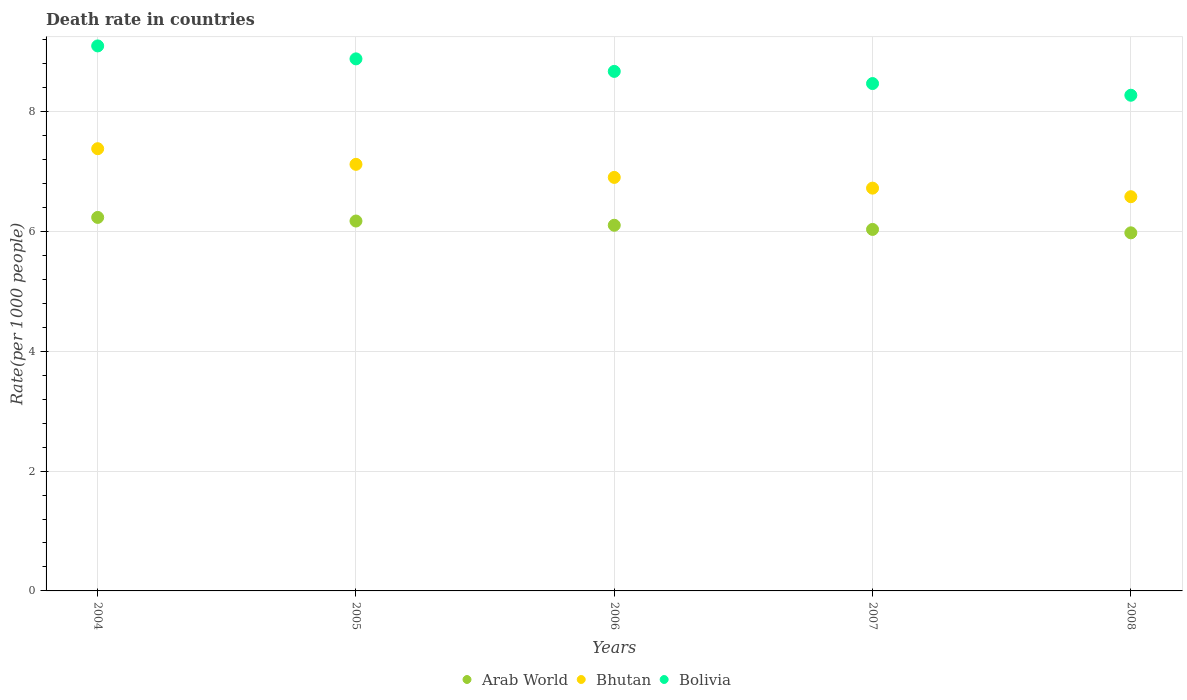How many different coloured dotlines are there?
Your answer should be compact. 3. What is the death rate in Bhutan in 2005?
Ensure brevity in your answer.  7.12. Across all years, what is the maximum death rate in Bolivia?
Keep it short and to the point. 9.09. Across all years, what is the minimum death rate in Arab World?
Offer a terse response. 5.98. In which year was the death rate in Bolivia maximum?
Your answer should be very brief. 2004. What is the total death rate in Arab World in the graph?
Provide a short and direct response. 30.51. What is the difference between the death rate in Arab World in 2004 and that in 2008?
Your response must be concise. 0.26. What is the difference between the death rate in Bolivia in 2006 and the death rate in Bhutan in 2008?
Provide a succinct answer. 2.09. What is the average death rate in Bhutan per year?
Offer a very short reply. 6.94. In the year 2005, what is the difference between the death rate in Bhutan and death rate in Bolivia?
Offer a terse response. -1.76. What is the ratio of the death rate in Bolivia in 2004 to that in 2008?
Your response must be concise. 1.1. Is the difference between the death rate in Bhutan in 2004 and 2007 greater than the difference between the death rate in Bolivia in 2004 and 2007?
Your response must be concise. Yes. What is the difference between the highest and the second highest death rate in Bhutan?
Offer a very short reply. 0.26. What is the difference between the highest and the lowest death rate in Bolivia?
Your answer should be compact. 0.82. In how many years, is the death rate in Bhutan greater than the average death rate in Bhutan taken over all years?
Offer a terse response. 2. Is it the case that in every year, the sum of the death rate in Bolivia and death rate in Bhutan  is greater than the death rate in Arab World?
Provide a short and direct response. Yes. How many dotlines are there?
Your response must be concise. 3. How many years are there in the graph?
Make the answer very short. 5. Are the values on the major ticks of Y-axis written in scientific E-notation?
Ensure brevity in your answer.  No. Does the graph contain any zero values?
Make the answer very short. No. How are the legend labels stacked?
Your answer should be very brief. Horizontal. What is the title of the graph?
Offer a terse response. Death rate in countries. What is the label or title of the X-axis?
Provide a short and direct response. Years. What is the label or title of the Y-axis?
Offer a terse response. Rate(per 1000 people). What is the Rate(per 1000 people) in Arab World in 2004?
Make the answer very short. 6.23. What is the Rate(per 1000 people) in Bhutan in 2004?
Keep it short and to the point. 7.38. What is the Rate(per 1000 people) of Bolivia in 2004?
Ensure brevity in your answer.  9.09. What is the Rate(per 1000 people) in Arab World in 2005?
Provide a short and direct response. 6.17. What is the Rate(per 1000 people) of Bhutan in 2005?
Ensure brevity in your answer.  7.12. What is the Rate(per 1000 people) of Bolivia in 2005?
Provide a succinct answer. 8.88. What is the Rate(per 1000 people) in Arab World in 2006?
Your answer should be very brief. 6.1. What is the Rate(per 1000 people) of Bolivia in 2006?
Your answer should be very brief. 8.67. What is the Rate(per 1000 people) in Arab World in 2007?
Your response must be concise. 6.03. What is the Rate(per 1000 people) in Bhutan in 2007?
Offer a very short reply. 6.72. What is the Rate(per 1000 people) of Bolivia in 2007?
Your response must be concise. 8.47. What is the Rate(per 1000 people) of Arab World in 2008?
Your answer should be very brief. 5.98. What is the Rate(per 1000 people) in Bhutan in 2008?
Your response must be concise. 6.58. What is the Rate(per 1000 people) in Bolivia in 2008?
Keep it short and to the point. 8.27. Across all years, what is the maximum Rate(per 1000 people) in Arab World?
Provide a short and direct response. 6.23. Across all years, what is the maximum Rate(per 1000 people) in Bhutan?
Offer a terse response. 7.38. Across all years, what is the maximum Rate(per 1000 people) of Bolivia?
Make the answer very short. 9.09. Across all years, what is the minimum Rate(per 1000 people) in Arab World?
Keep it short and to the point. 5.98. Across all years, what is the minimum Rate(per 1000 people) of Bhutan?
Provide a short and direct response. 6.58. Across all years, what is the minimum Rate(per 1000 people) of Bolivia?
Ensure brevity in your answer.  8.27. What is the total Rate(per 1000 people) in Arab World in the graph?
Ensure brevity in your answer.  30.51. What is the total Rate(per 1000 people) of Bhutan in the graph?
Provide a short and direct response. 34.7. What is the total Rate(per 1000 people) of Bolivia in the graph?
Make the answer very short. 43.38. What is the difference between the Rate(per 1000 people) of Arab World in 2004 and that in 2005?
Offer a terse response. 0.06. What is the difference between the Rate(per 1000 people) in Bhutan in 2004 and that in 2005?
Your answer should be compact. 0.26. What is the difference between the Rate(per 1000 people) in Bolivia in 2004 and that in 2005?
Offer a very short reply. 0.22. What is the difference between the Rate(per 1000 people) of Arab World in 2004 and that in 2006?
Provide a short and direct response. 0.13. What is the difference between the Rate(per 1000 people) in Bhutan in 2004 and that in 2006?
Provide a succinct answer. 0.48. What is the difference between the Rate(per 1000 people) in Bolivia in 2004 and that in 2006?
Provide a succinct answer. 0.42. What is the difference between the Rate(per 1000 people) of Arab World in 2004 and that in 2007?
Offer a very short reply. 0.2. What is the difference between the Rate(per 1000 people) of Bhutan in 2004 and that in 2007?
Make the answer very short. 0.66. What is the difference between the Rate(per 1000 people) in Bolivia in 2004 and that in 2007?
Make the answer very short. 0.63. What is the difference between the Rate(per 1000 people) in Arab World in 2004 and that in 2008?
Offer a terse response. 0.26. What is the difference between the Rate(per 1000 people) in Bhutan in 2004 and that in 2008?
Make the answer very short. 0.8. What is the difference between the Rate(per 1000 people) of Bolivia in 2004 and that in 2008?
Your response must be concise. 0.82. What is the difference between the Rate(per 1000 people) of Arab World in 2005 and that in 2006?
Provide a short and direct response. 0.07. What is the difference between the Rate(per 1000 people) of Bhutan in 2005 and that in 2006?
Offer a very short reply. 0.22. What is the difference between the Rate(per 1000 people) in Bolivia in 2005 and that in 2006?
Give a very brief answer. 0.21. What is the difference between the Rate(per 1000 people) in Arab World in 2005 and that in 2007?
Offer a terse response. 0.14. What is the difference between the Rate(per 1000 people) in Bhutan in 2005 and that in 2007?
Make the answer very short. 0.4. What is the difference between the Rate(per 1000 people) of Bolivia in 2005 and that in 2007?
Provide a short and direct response. 0.41. What is the difference between the Rate(per 1000 people) in Arab World in 2005 and that in 2008?
Your answer should be compact. 0.2. What is the difference between the Rate(per 1000 people) in Bhutan in 2005 and that in 2008?
Keep it short and to the point. 0.54. What is the difference between the Rate(per 1000 people) in Bolivia in 2005 and that in 2008?
Offer a terse response. 0.61. What is the difference between the Rate(per 1000 people) of Arab World in 2006 and that in 2007?
Your answer should be compact. 0.07. What is the difference between the Rate(per 1000 people) in Bhutan in 2006 and that in 2007?
Ensure brevity in your answer.  0.18. What is the difference between the Rate(per 1000 people) in Bolivia in 2006 and that in 2007?
Your answer should be compact. 0.2. What is the difference between the Rate(per 1000 people) in Arab World in 2006 and that in 2008?
Make the answer very short. 0.13. What is the difference between the Rate(per 1000 people) in Bhutan in 2006 and that in 2008?
Offer a terse response. 0.32. What is the difference between the Rate(per 1000 people) of Bolivia in 2006 and that in 2008?
Give a very brief answer. 0.4. What is the difference between the Rate(per 1000 people) of Arab World in 2007 and that in 2008?
Provide a short and direct response. 0.06. What is the difference between the Rate(per 1000 people) of Bhutan in 2007 and that in 2008?
Your answer should be compact. 0.14. What is the difference between the Rate(per 1000 people) in Bolivia in 2007 and that in 2008?
Keep it short and to the point. 0.2. What is the difference between the Rate(per 1000 people) in Arab World in 2004 and the Rate(per 1000 people) in Bhutan in 2005?
Your answer should be very brief. -0.89. What is the difference between the Rate(per 1000 people) in Arab World in 2004 and the Rate(per 1000 people) in Bolivia in 2005?
Offer a very short reply. -2.65. What is the difference between the Rate(per 1000 people) of Bhutan in 2004 and the Rate(per 1000 people) of Bolivia in 2005?
Offer a very short reply. -1.5. What is the difference between the Rate(per 1000 people) of Arab World in 2004 and the Rate(per 1000 people) of Bhutan in 2006?
Your answer should be very brief. -0.67. What is the difference between the Rate(per 1000 people) of Arab World in 2004 and the Rate(per 1000 people) of Bolivia in 2006?
Offer a very short reply. -2.44. What is the difference between the Rate(per 1000 people) in Bhutan in 2004 and the Rate(per 1000 people) in Bolivia in 2006?
Make the answer very short. -1.29. What is the difference between the Rate(per 1000 people) of Arab World in 2004 and the Rate(per 1000 people) of Bhutan in 2007?
Provide a succinct answer. -0.49. What is the difference between the Rate(per 1000 people) of Arab World in 2004 and the Rate(per 1000 people) of Bolivia in 2007?
Keep it short and to the point. -2.23. What is the difference between the Rate(per 1000 people) of Bhutan in 2004 and the Rate(per 1000 people) of Bolivia in 2007?
Offer a very short reply. -1.09. What is the difference between the Rate(per 1000 people) in Arab World in 2004 and the Rate(per 1000 people) in Bhutan in 2008?
Keep it short and to the point. -0.35. What is the difference between the Rate(per 1000 people) in Arab World in 2004 and the Rate(per 1000 people) in Bolivia in 2008?
Your answer should be very brief. -2.04. What is the difference between the Rate(per 1000 people) of Bhutan in 2004 and the Rate(per 1000 people) of Bolivia in 2008?
Provide a succinct answer. -0.89. What is the difference between the Rate(per 1000 people) of Arab World in 2005 and the Rate(per 1000 people) of Bhutan in 2006?
Your response must be concise. -0.73. What is the difference between the Rate(per 1000 people) in Arab World in 2005 and the Rate(per 1000 people) in Bolivia in 2006?
Offer a terse response. -2.5. What is the difference between the Rate(per 1000 people) of Bhutan in 2005 and the Rate(per 1000 people) of Bolivia in 2006?
Offer a terse response. -1.55. What is the difference between the Rate(per 1000 people) in Arab World in 2005 and the Rate(per 1000 people) in Bhutan in 2007?
Offer a terse response. -0.55. What is the difference between the Rate(per 1000 people) in Arab World in 2005 and the Rate(per 1000 people) in Bolivia in 2007?
Offer a very short reply. -2.29. What is the difference between the Rate(per 1000 people) of Bhutan in 2005 and the Rate(per 1000 people) of Bolivia in 2007?
Your answer should be very brief. -1.35. What is the difference between the Rate(per 1000 people) in Arab World in 2005 and the Rate(per 1000 people) in Bhutan in 2008?
Offer a very short reply. -0.41. What is the difference between the Rate(per 1000 people) in Arab World in 2005 and the Rate(per 1000 people) in Bolivia in 2008?
Provide a succinct answer. -2.1. What is the difference between the Rate(per 1000 people) in Bhutan in 2005 and the Rate(per 1000 people) in Bolivia in 2008?
Ensure brevity in your answer.  -1.15. What is the difference between the Rate(per 1000 people) of Arab World in 2006 and the Rate(per 1000 people) of Bhutan in 2007?
Offer a very short reply. -0.62. What is the difference between the Rate(per 1000 people) in Arab World in 2006 and the Rate(per 1000 people) in Bolivia in 2007?
Your answer should be compact. -2.36. What is the difference between the Rate(per 1000 people) in Bhutan in 2006 and the Rate(per 1000 people) in Bolivia in 2007?
Offer a terse response. -1.57. What is the difference between the Rate(per 1000 people) in Arab World in 2006 and the Rate(per 1000 people) in Bhutan in 2008?
Provide a succinct answer. -0.48. What is the difference between the Rate(per 1000 people) of Arab World in 2006 and the Rate(per 1000 people) of Bolivia in 2008?
Provide a succinct answer. -2.17. What is the difference between the Rate(per 1000 people) of Bhutan in 2006 and the Rate(per 1000 people) of Bolivia in 2008?
Offer a terse response. -1.37. What is the difference between the Rate(per 1000 people) in Arab World in 2007 and the Rate(per 1000 people) in Bhutan in 2008?
Give a very brief answer. -0.55. What is the difference between the Rate(per 1000 people) in Arab World in 2007 and the Rate(per 1000 people) in Bolivia in 2008?
Offer a very short reply. -2.24. What is the difference between the Rate(per 1000 people) in Bhutan in 2007 and the Rate(per 1000 people) in Bolivia in 2008?
Provide a succinct answer. -1.55. What is the average Rate(per 1000 people) in Arab World per year?
Give a very brief answer. 6.1. What is the average Rate(per 1000 people) in Bhutan per year?
Offer a terse response. 6.94. What is the average Rate(per 1000 people) in Bolivia per year?
Provide a succinct answer. 8.68. In the year 2004, what is the difference between the Rate(per 1000 people) of Arab World and Rate(per 1000 people) of Bhutan?
Offer a very short reply. -1.15. In the year 2004, what is the difference between the Rate(per 1000 people) of Arab World and Rate(per 1000 people) of Bolivia?
Give a very brief answer. -2.86. In the year 2004, what is the difference between the Rate(per 1000 people) in Bhutan and Rate(per 1000 people) in Bolivia?
Your answer should be very brief. -1.72. In the year 2005, what is the difference between the Rate(per 1000 people) in Arab World and Rate(per 1000 people) in Bhutan?
Make the answer very short. -0.95. In the year 2005, what is the difference between the Rate(per 1000 people) in Arab World and Rate(per 1000 people) in Bolivia?
Make the answer very short. -2.71. In the year 2005, what is the difference between the Rate(per 1000 people) of Bhutan and Rate(per 1000 people) of Bolivia?
Keep it short and to the point. -1.76. In the year 2006, what is the difference between the Rate(per 1000 people) of Arab World and Rate(per 1000 people) of Bhutan?
Provide a succinct answer. -0.8. In the year 2006, what is the difference between the Rate(per 1000 people) of Arab World and Rate(per 1000 people) of Bolivia?
Your answer should be very brief. -2.57. In the year 2006, what is the difference between the Rate(per 1000 people) of Bhutan and Rate(per 1000 people) of Bolivia?
Provide a succinct answer. -1.77. In the year 2007, what is the difference between the Rate(per 1000 people) in Arab World and Rate(per 1000 people) in Bhutan?
Your answer should be very brief. -0.69. In the year 2007, what is the difference between the Rate(per 1000 people) in Arab World and Rate(per 1000 people) in Bolivia?
Provide a succinct answer. -2.43. In the year 2007, what is the difference between the Rate(per 1000 people) in Bhutan and Rate(per 1000 people) in Bolivia?
Provide a short and direct response. -1.75. In the year 2008, what is the difference between the Rate(per 1000 people) of Arab World and Rate(per 1000 people) of Bhutan?
Your answer should be compact. -0.6. In the year 2008, what is the difference between the Rate(per 1000 people) of Arab World and Rate(per 1000 people) of Bolivia?
Your answer should be compact. -2.3. In the year 2008, what is the difference between the Rate(per 1000 people) of Bhutan and Rate(per 1000 people) of Bolivia?
Make the answer very short. -1.69. What is the ratio of the Rate(per 1000 people) in Arab World in 2004 to that in 2005?
Your answer should be compact. 1.01. What is the ratio of the Rate(per 1000 people) of Bhutan in 2004 to that in 2005?
Make the answer very short. 1.04. What is the ratio of the Rate(per 1000 people) of Bolivia in 2004 to that in 2005?
Keep it short and to the point. 1.02. What is the ratio of the Rate(per 1000 people) in Arab World in 2004 to that in 2006?
Offer a very short reply. 1.02. What is the ratio of the Rate(per 1000 people) in Bhutan in 2004 to that in 2006?
Provide a succinct answer. 1.07. What is the ratio of the Rate(per 1000 people) in Bolivia in 2004 to that in 2006?
Offer a terse response. 1.05. What is the ratio of the Rate(per 1000 people) of Arab World in 2004 to that in 2007?
Provide a succinct answer. 1.03. What is the ratio of the Rate(per 1000 people) of Bhutan in 2004 to that in 2007?
Your response must be concise. 1.1. What is the ratio of the Rate(per 1000 people) in Bolivia in 2004 to that in 2007?
Provide a short and direct response. 1.07. What is the ratio of the Rate(per 1000 people) of Arab World in 2004 to that in 2008?
Keep it short and to the point. 1.04. What is the ratio of the Rate(per 1000 people) of Bhutan in 2004 to that in 2008?
Make the answer very short. 1.12. What is the ratio of the Rate(per 1000 people) of Bolivia in 2004 to that in 2008?
Make the answer very short. 1.1. What is the ratio of the Rate(per 1000 people) in Arab World in 2005 to that in 2006?
Give a very brief answer. 1.01. What is the ratio of the Rate(per 1000 people) in Bhutan in 2005 to that in 2006?
Provide a succinct answer. 1.03. What is the ratio of the Rate(per 1000 people) in Bolivia in 2005 to that in 2006?
Your response must be concise. 1.02. What is the ratio of the Rate(per 1000 people) of Arab World in 2005 to that in 2007?
Give a very brief answer. 1.02. What is the ratio of the Rate(per 1000 people) of Bhutan in 2005 to that in 2007?
Offer a terse response. 1.06. What is the ratio of the Rate(per 1000 people) in Bolivia in 2005 to that in 2007?
Keep it short and to the point. 1.05. What is the ratio of the Rate(per 1000 people) in Arab World in 2005 to that in 2008?
Offer a terse response. 1.03. What is the ratio of the Rate(per 1000 people) of Bhutan in 2005 to that in 2008?
Offer a very short reply. 1.08. What is the ratio of the Rate(per 1000 people) of Bolivia in 2005 to that in 2008?
Keep it short and to the point. 1.07. What is the ratio of the Rate(per 1000 people) of Arab World in 2006 to that in 2007?
Your answer should be very brief. 1.01. What is the ratio of the Rate(per 1000 people) of Bhutan in 2006 to that in 2007?
Offer a very short reply. 1.03. What is the ratio of the Rate(per 1000 people) of Bolivia in 2006 to that in 2007?
Offer a terse response. 1.02. What is the ratio of the Rate(per 1000 people) of Arab World in 2006 to that in 2008?
Give a very brief answer. 1.02. What is the ratio of the Rate(per 1000 people) in Bhutan in 2006 to that in 2008?
Ensure brevity in your answer.  1.05. What is the ratio of the Rate(per 1000 people) in Bolivia in 2006 to that in 2008?
Your response must be concise. 1.05. What is the ratio of the Rate(per 1000 people) of Arab World in 2007 to that in 2008?
Offer a very short reply. 1.01. What is the ratio of the Rate(per 1000 people) in Bhutan in 2007 to that in 2008?
Your answer should be compact. 1.02. What is the ratio of the Rate(per 1000 people) of Bolivia in 2007 to that in 2008?
Your answer should be very brief. 1.02. What is the difference between the highest and the second highest Rate(per 1000 people) in Arab World?
Offer a terse response. 0.06. What is the difference between the highest and the second highest Rate(per 1000 people) in Bhutan?
Your answer should be compact. 0.26. What is the difference between the highest and the second highest Rate(per 1000 people) of Bolivia?
Keep it short and to the point. 0.22. What is the difference between the highest and the lowest Rate(per 1000 people) in Arab World?
Offer a very short reply. 0.26. What is the difference between the highest and the lowest Rate(per 1000 people) in Bhutan?
Offer a very short reply. 0.8. What is the difference between the highest and the lowest Rate(per 1000 people) in Bolivia?
Offer a terse response. 0.82. 